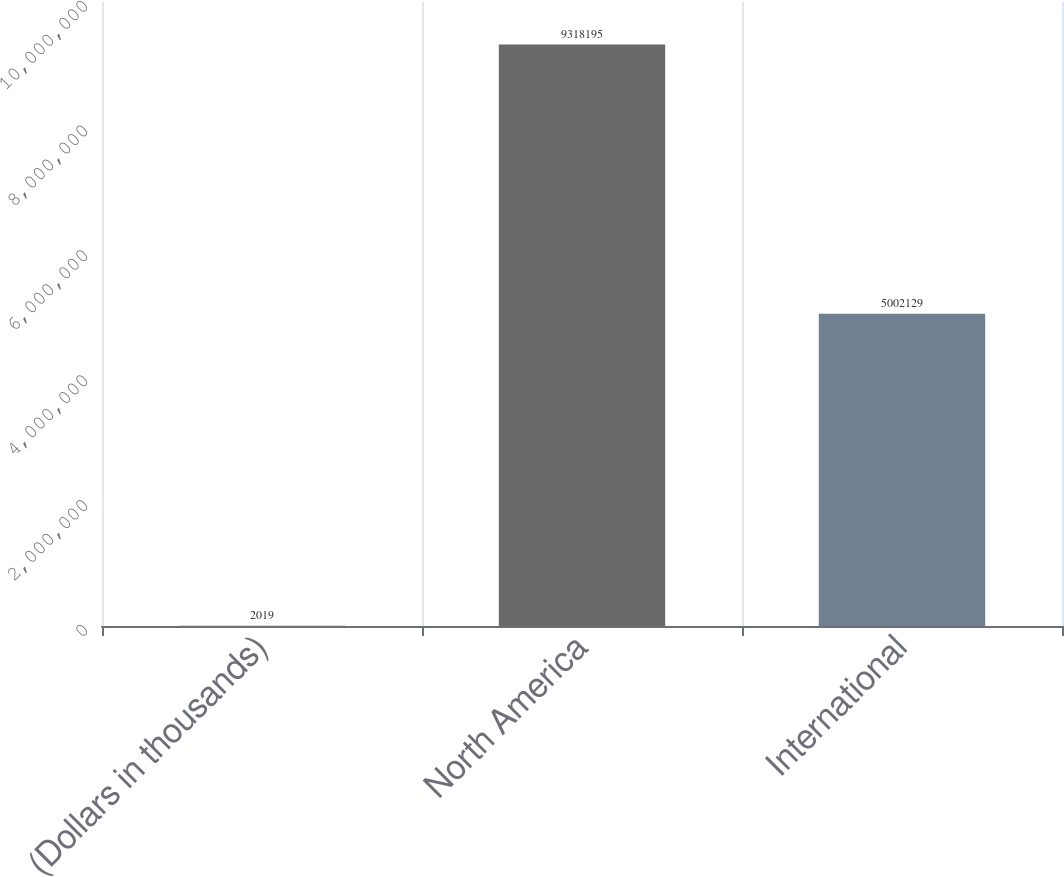<chart> <loc_0><loc_0><loc_500><loc_500><bar_chart><fcel>(Dollars in thousands)<fcel>North America<fcel>International<nl><fcel>2019<fcel>9.3182e+06<fcel>5.00213e+06<nl></chart> 